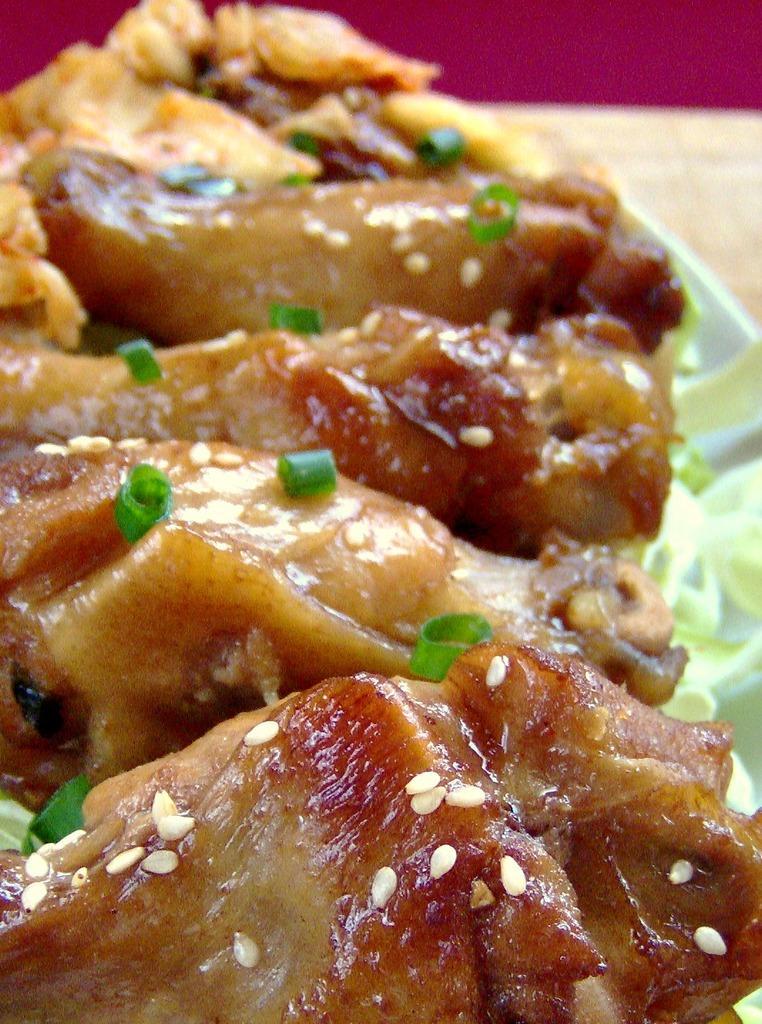How would you summarize this image in a sentence or two? In this picture we can see some food items on the plate. 